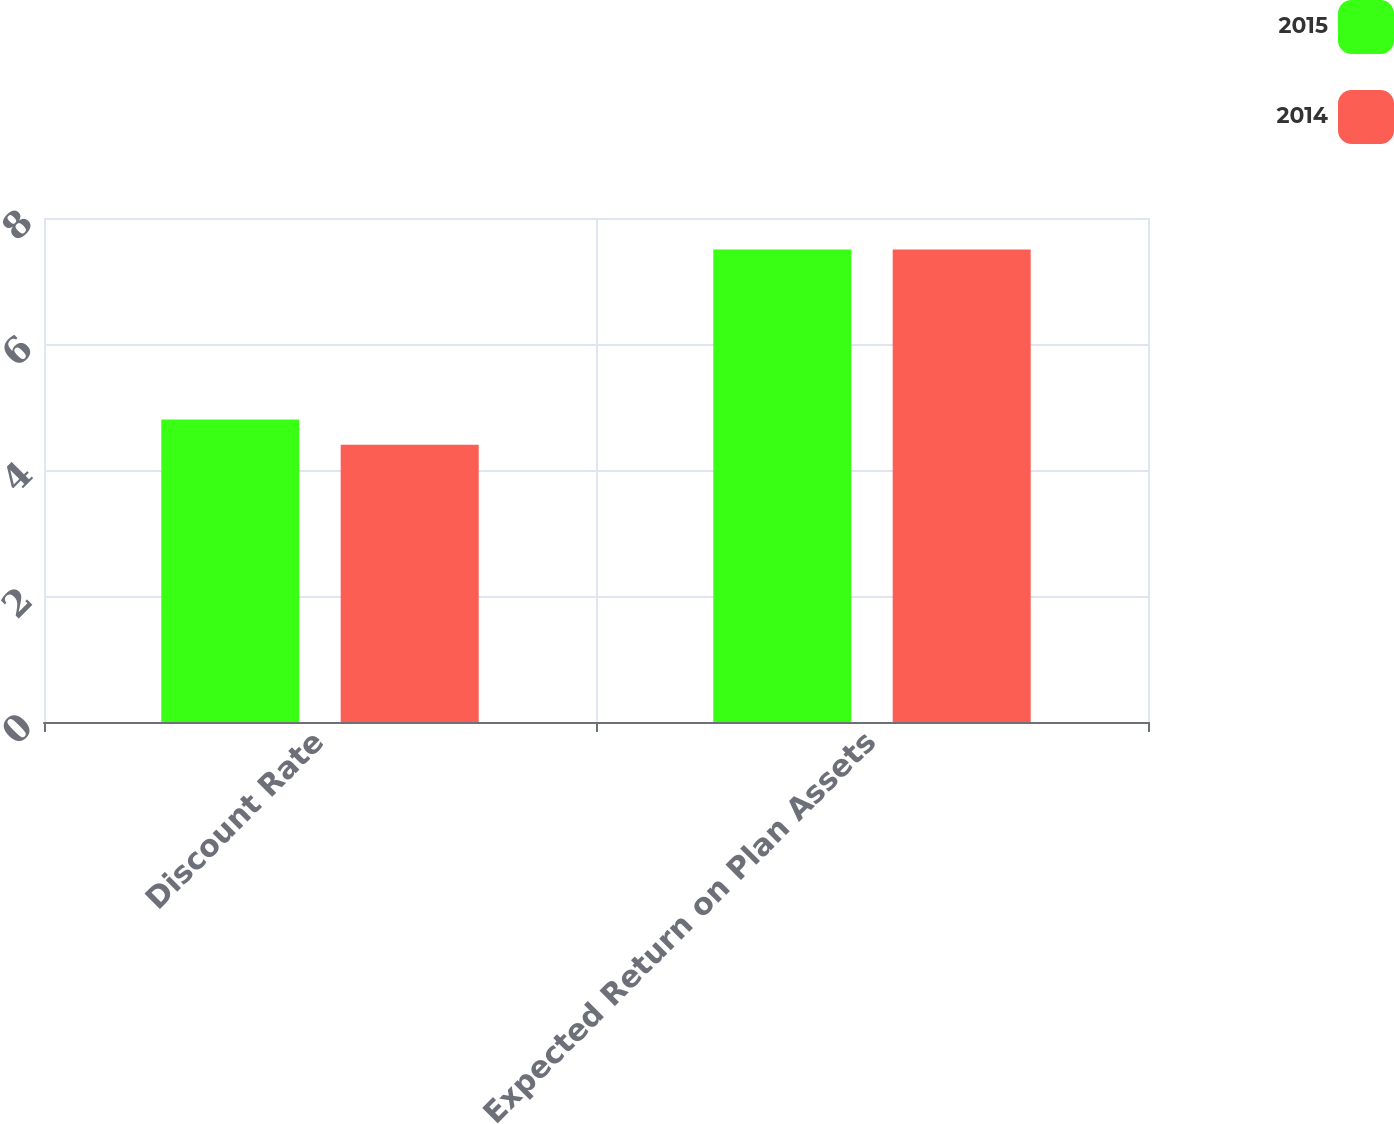Convert chart to OTSL. <chart><loc_0><loc_0><loc_500><loc_500><stacked_bar_chart><ecel><fcel>Discount Rate<fcel>Expected Return on Plan Assets<nl><fcel>2015<fcel>4.8<fcel>7.5<nl><fcel>2014<fcel>4.4<fcel>7.5<nl></chart> 